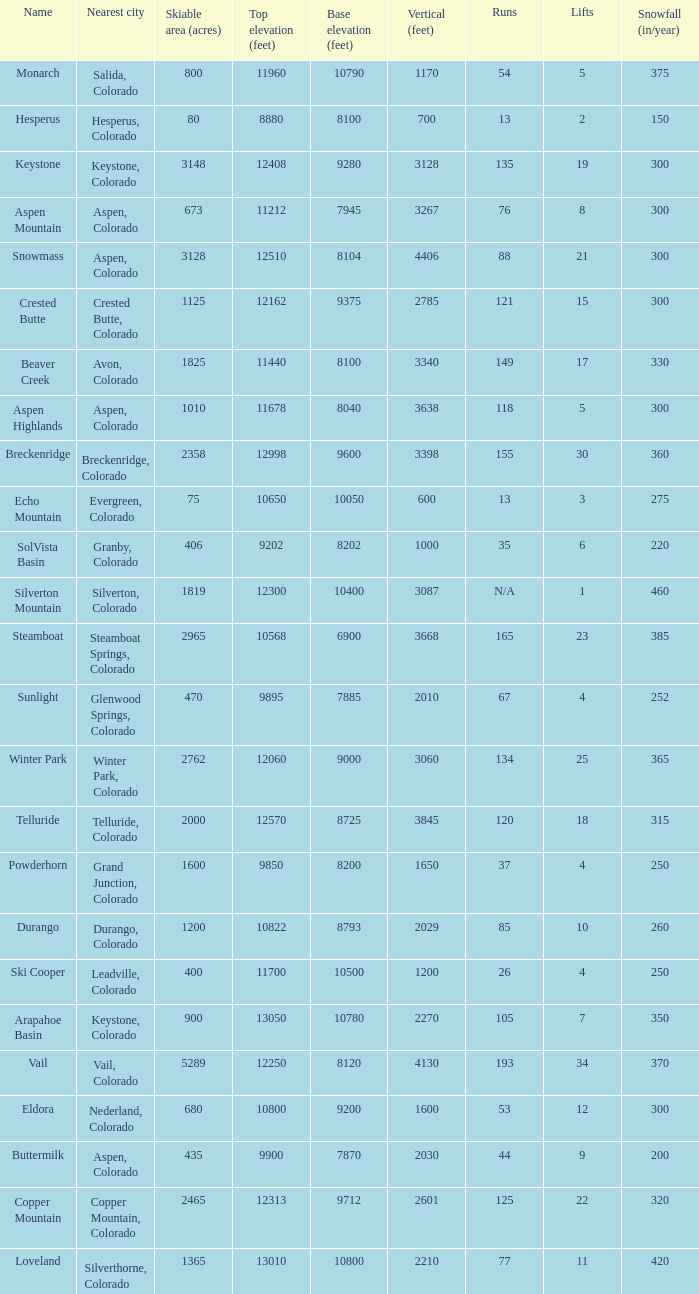If the name is Steamboat, what is the top elevation? 10568.0. 